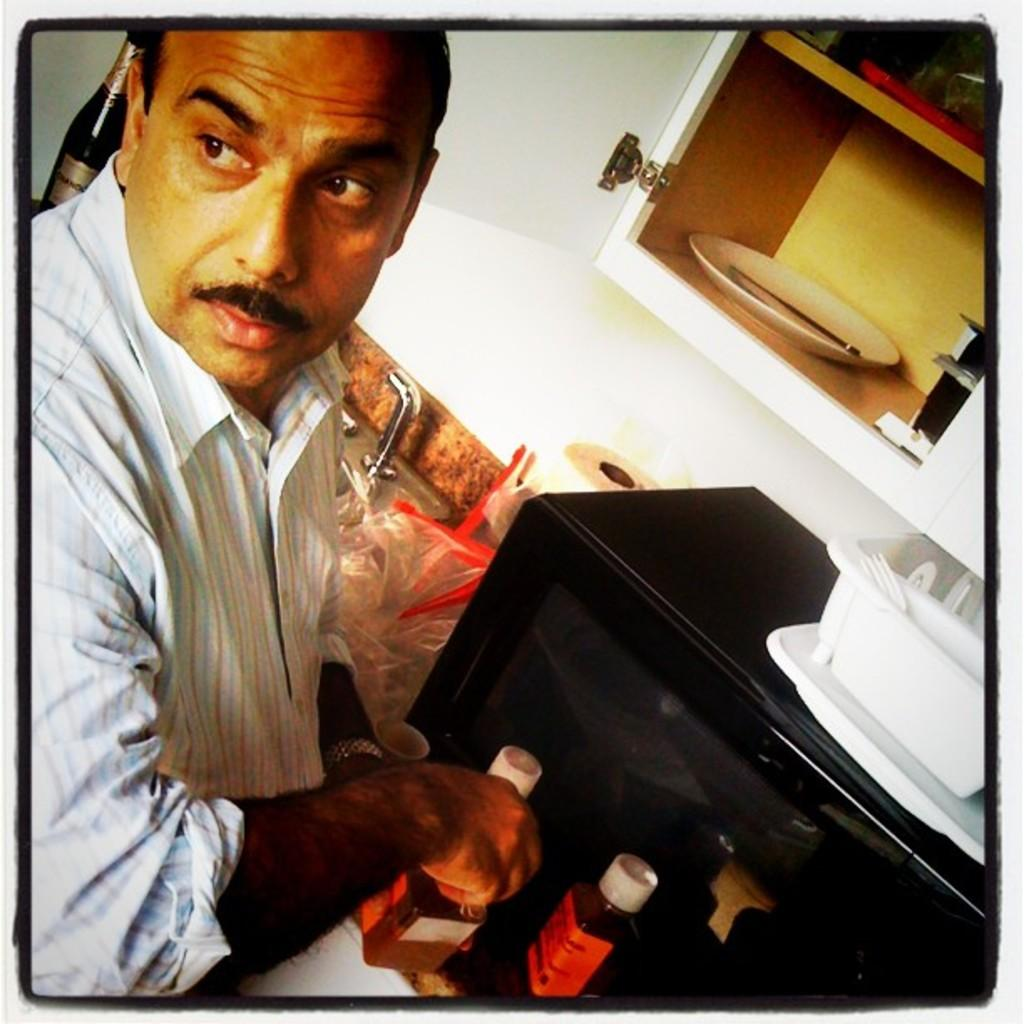Who or what is present in the image? There is a person in the image. What appliance can be seen in the image? There is an oven in the image. What object is used for serving food in the image? There is a plate in the image. What is the container used for in the image? The container is used for holding or storing something. What piece of furniture is visible at the top of the image? There is a cupboard at the top of the image. What type of mitten is the person wearing in the image? There is no mitten present in the image. How does the hydrant affect the person's cooking in the image? There is no hydrant present in the image, so it does not affect the person's cooking. 